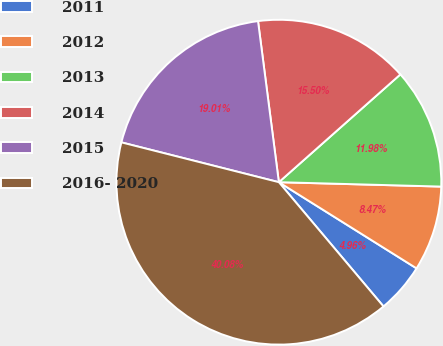Convert chart to OTSL. <chart><loc_0><loc_0><loc_500><loc_500><pie_chart><fcel>2011<fcel>2012<fcel>2013<fcel>2014<fcel>2015<fcel>2016- 2020<nl><fcel>4.96%<fcel>8.47%<fcel>11.98%<fcel>15.5%<fcel>19.01%<fcel>40.08%<nl></chart> 